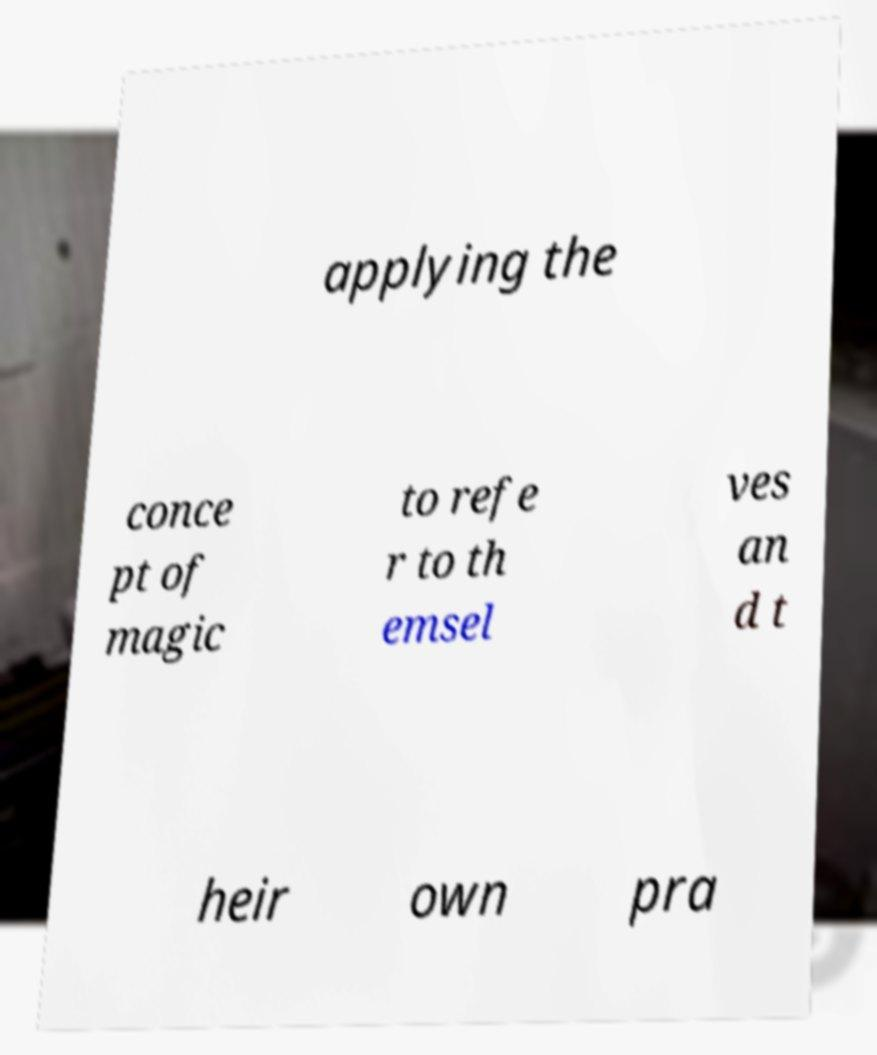I need the written content from this picture converted into text. Can you do that? applying the conce pt of magic to refe r to th emsel ves an d t heir own pra 